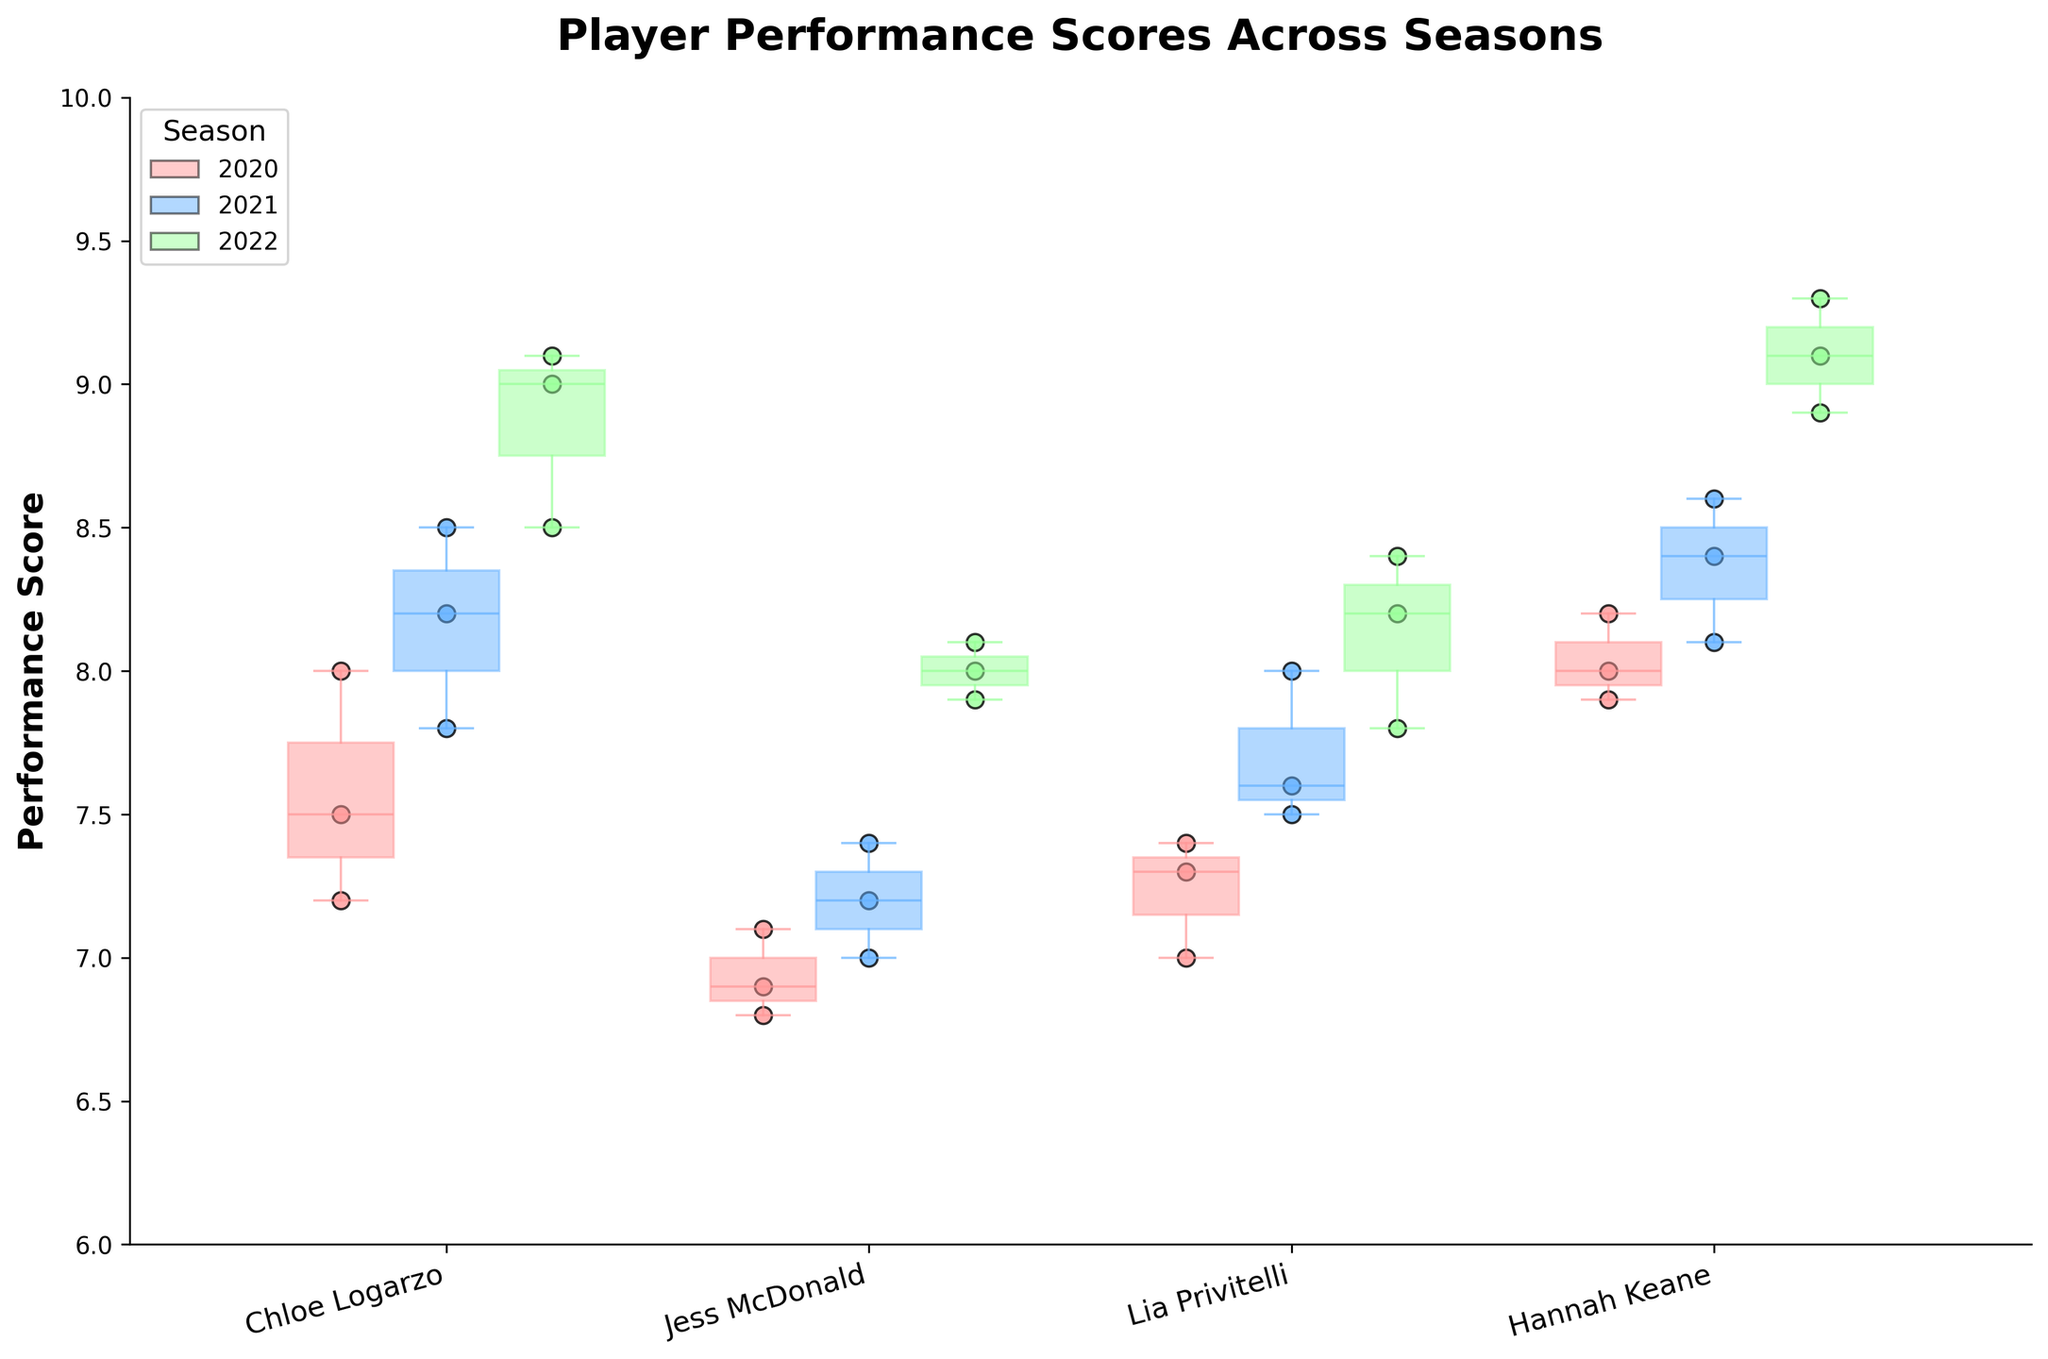What's the title of the plot? The title of the plot is usually placed at the top center and provides a summary of the plot's content. In this case, it reads "Player Performance Scores Across Seasons".
Answer: Player Performance Scores Across Seasons Which player has the highest median performance score in the 2022 season? To find this, we look at the median lines inside the 2022 season's boxplots. Identify the highest median value among the players. Hannah Keane's median appears to be the highest.
Answer: Hannah Keane How many seasons are shown in the plot, and which ones are they? The legend shows different colored patches representing each season, and the axis labels help identify the seasons. There are three seasons: 2020, 2021, and 2022.
Answer: Three: 2020, 2021, 2022 For Chloe Logarzo, in which season does she have the most consistent performance? Consistency can be inferred from the box length; shorter boxes indicate more consistency. Chloe Logarzo's shortest box is in the 2021 season.
Answer: 2021 Who had the lowest single performance score throughout all seasons? Examine the lowest points for each player's scatter points. Jess McDonald has the lowest single score of 6.8 in 2020.
Answer: Jess McDonald Between Jess McDonald and Chloe Logarzo, who improved more from 2020 to 2021? Calculate the difference in median values of both players from 2020 to 2021. Chloe Logarzo's median increased more substantially from 7.5 to 8.2 compared to Jess McDonald's increase from 6.9 to 7.2.
Answer: Chloe Logarzo What does a scatter point outside of the box suggest about that particular performance score? In a box plot, scatter points outside the box (and often beyond the "whiskers") are typically considered outliers, indicating a performance score that is significantly different from the typical range for that group.
Answer: It's an outlier Between 2020 and 2022, who showed the greatest improvement in their median performance score? Assess the median values of each player in 2020 and compare them to the median values in 2022. Hannah Keane's median increased from 8.0 in 2020 to 9.1 in 2022, showing the greatest improvement.
Answer: Hannah Keane 